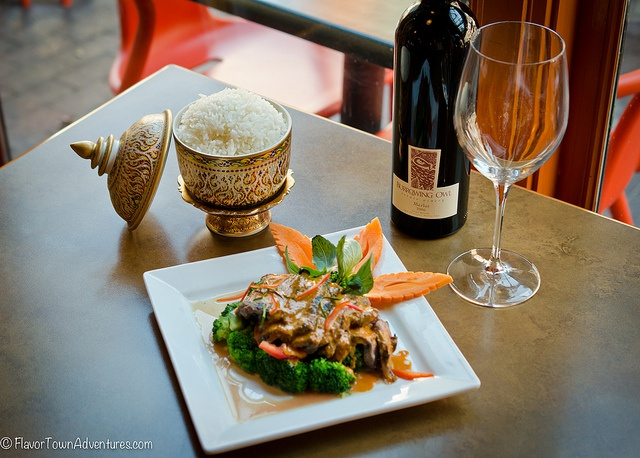Describe the objects in this image and their specific colors. I can see dining table in black, darkgray, gray, and olive tones, wine glass in black, maroon, brown, gray, and darkgray tones, bottle in black, tan, maroon, and gray tones, chair in black, lightgray, lightpink, salmon, and red tones, and bowl in black, lightgray, darkgray, olive, and tan tones in this image. 